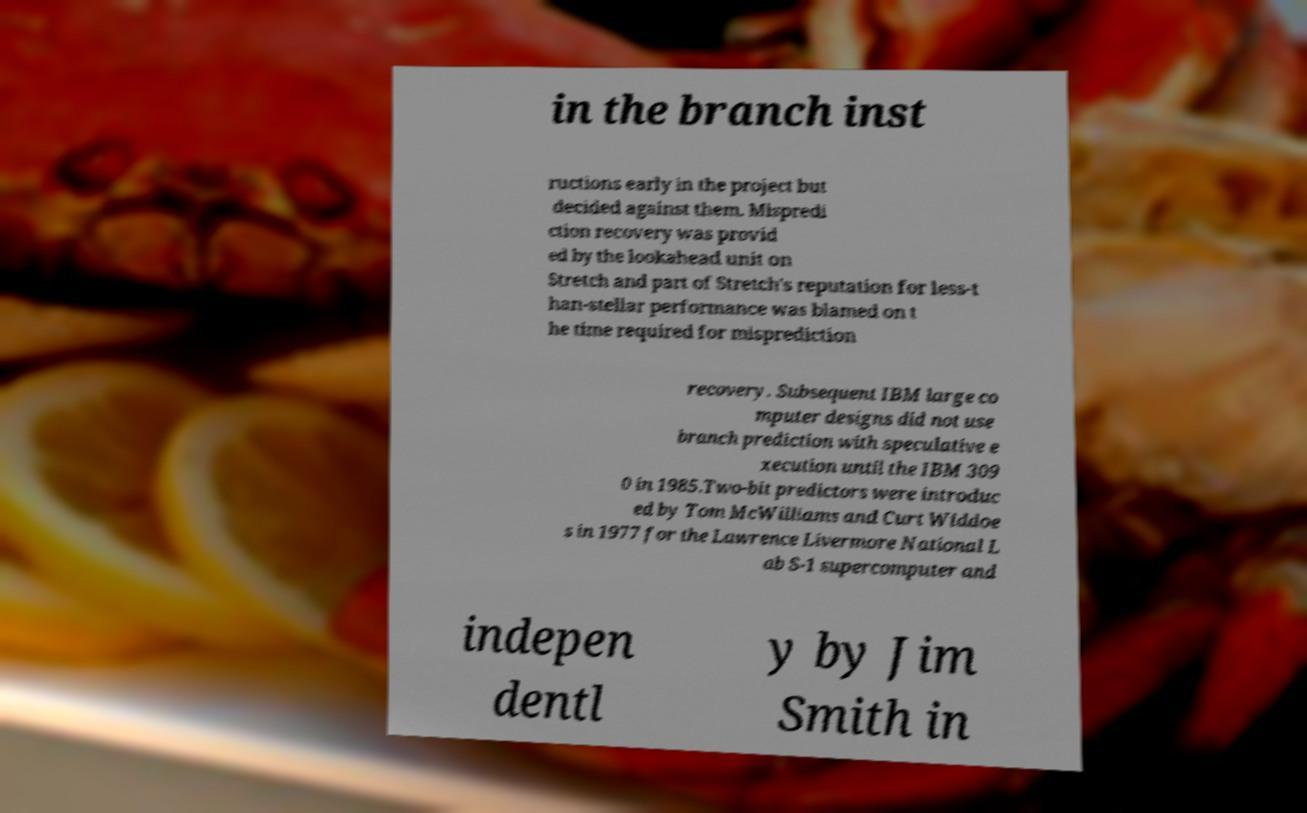Can you read and provide the text displayed in the image?This photo seems to have some interesting text. Can you extract and type it out for me? in the branch inst ructions early in the project but decided against them. Mispredi ction recovery was provid ed by the lookahead unit on Stretch and part of Stretch's reputation for less-t han-stellar performance was blamed on t he time required for misprediction recovery. Subsequent IBM large co mputer designs did not use branch prediction with speculative e xecution until the IBM 309 0 in 1985.Two-bit predictors were introduc ed by Tom McWilliams and Curt Widdoe s in 1977 for the Lawrence Livermore National L ab S-1 supercomputer and indepen dentl y by Jim Smith in 